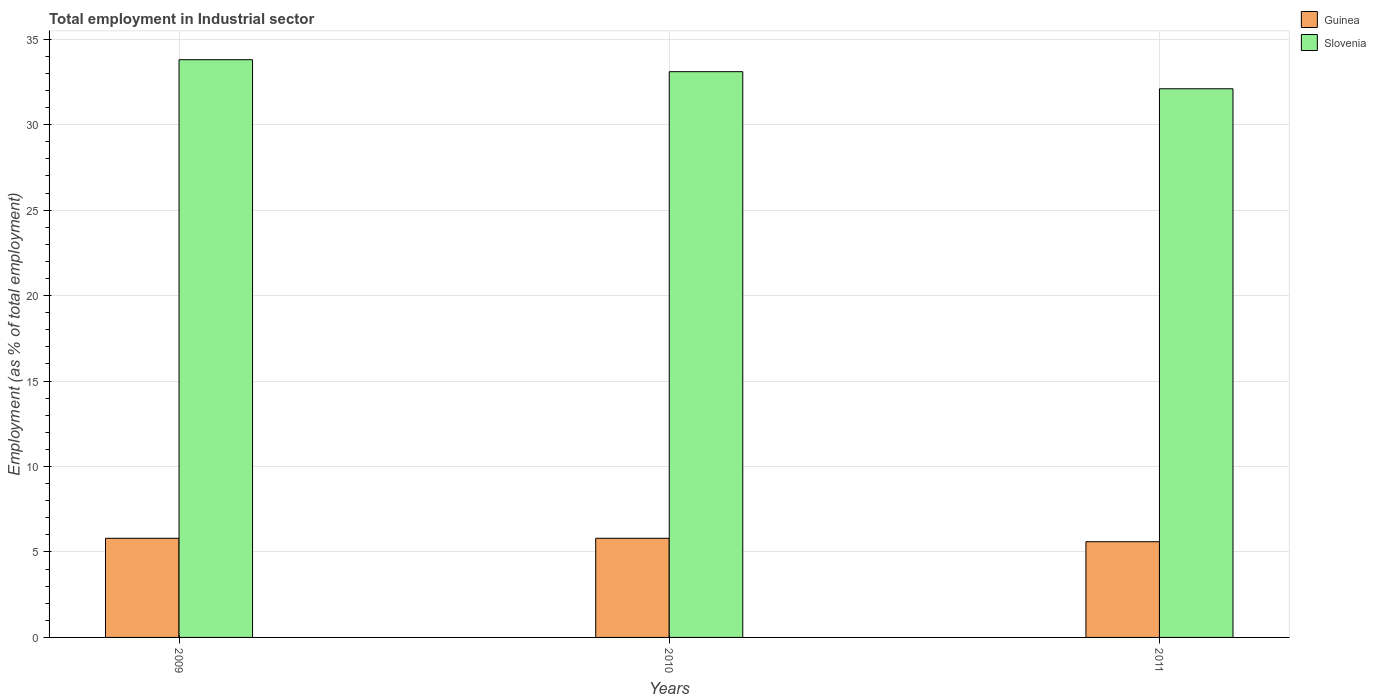How many different coloured bars are there?
Your answer should be compact. 2. How many groups of bars are there?
Make the answer very short. 3. Are the number of bars per tick equal to the number of legend labels?
Make the answer very short. Yes. How many bars are there on the 3rd tick from the left?
Your response must be concise. 2. What is the label of the 2nd group of bars from the left?
Give a very brief answer. 2010. In how many cases, is the number of bars for a given year not equal to the number of legend labels?
Your answer should be compact. 0. What is the employment in industrial sector in Guinea in 2011?
Offer a terse response. 5.6. Across all years, what is the maximum employment in industrial sector in Slovenia?
Ensure brevity in your answer.  33.8. Across all years, what is the minimum employment in industrial sector in Guinea?
Provide a succinct answer. 5.6. In which year was the employment in industrial sector in Guinea maximum?
Give a very brief answer. 2009. In which year was the employment in industrial sector in Guinea minimum?
Keep it short and to the point. 2011. What is the total employment in industrial sector in Slovenia in the graph?
Ensure brevity in your answer.  99. What is the difference between the employment in industrial sector in Guinea in 2010 and that in 2011?
Ensure brevity in your answer.  0.2. What is the difference between the employment in industrial sector in Guinea in 2010 and the employment in industrial sector in Slovenia in 2009?
Your answer should be compact. -28. What is the average employment in industrial sector in Guinea per year?
Keep it short and to the point. 5.73. In the year 2009, what is the difference between the employment in industrial sector in Guinea and employment in industrial sector in Slovenia?
Provide a succinct answer. -28. What is the ratio of the employment in industrial sector in Guinea in 2009 to that in 2011?
Provide a succinct answer. 1.04. What is the difference between the highest and the second highest employment in industrial sector in Slovenia?
Make the answer very short. 0.7. What is the difference between the highest and the lowest employment in industrial sector in Slovenia?
Your answer should be very brief. 1.7. In how many years, is the employment in industrial sector in Slovenia greater than the average employment in industrial sector in Slovenia taken over all years?
Your answer should be very brief. 2. Is the sum of the employment in industrial sector in Slovenia in 2009 and 2010 greater than the maximum employment in industrial sector in Guinea across all years?
Give a very brief answer. Yes. What does the 1st bar from the left in 2009 represents?
Provide a short and direct response. Guinea. What does the 2nd bar from the right in 2009 represents?
Make the answer very short. Guinea. Are all the bars in the graph horizontal?
Your answer should be very brief. No. How many years are there in the graph?
Make the answer very short. 3. Does the graph contain any zero values?
Ensure brevity in your answer.  No. How are the legend labels stacked?
Give a very brief answer. Vertical. What is the title of the graph?
Offer a very short reply. Total employment in Industrial sector. Does "High income" appear as one of the legend labels in the graph?
Provide a succinct answer. No. What is the label or title of the Y-axis?
Keep it short and to the point. Employment (as % of total employment). What is the Employment (as % of total employment) of Guinea in 2009?
Your answer should be compact. 5.8. What is the Employment (as % of total employment) in Slovenia in 2009?
Ensure brevity in your answer.  33.8. What is the Employment (as % of total employment) in Guinea in 2010?
Keep it short and to the point. 5.8. What is the Employment (as % of total employment) in Slovenia in 2010?
Offer a very short reply. 33.1. What is the Employment (as % of total employment) in Guinea in 2011?
Provide a short and direct response. 5.6. What is the Employment (as % of total employment) in Slovenia in 2011?
Provide a short and direct response. 32.1. Across all years, what is the maximum Employment (as % of total employment) in Guinea?
Provide a succinct answer. 5.8. Across all years, what is the maximum Employment (as % of total employment) in Slovenia?
Provide a succinct answer. 33.8. Across all years, what is the minimum Employment (as % of total employment) of Guinea?
Your response must be concise. 5.6. Across all years, what is the minimum Employment (as % of total employment) in Slovenia?
Make the answer very short. 32.1. What is the total Employment (as % of total employment) of Slovenia in the graph?
Make the answer very short. 99. What is the difference between the Employment (as % of total employment) in Guinea in 2009 and that in 2011?
Your response must be concise. 0.2. What is the difference between the Employment (as % of total employment) of Guinea in 2009 and the Employment (as % of total employment) of Slovenia in 2010?
Give a very brief answer. -27.3. What is the difference between the Employment (as % of total employment) of Guinea in 2009 and the Employment (as % of total employment) of Slovenia in 2011?
Your answer should be compact. -26.3. What is the difference between the Employment (as % of total employment) in Guinea in 2010 and the Employment (as % of total employment) in Slovenia in 2011?
Offer a very short reply. -26.3. What is the average Employment (as % of total employment) in Guinea per year?
Your answer should be very brief. 5.73. In the year 2009, what is the difference between the Employment (as % of total employment) of Guinea and Employment (as % of total employment) of Slovenia?
Keep it short and to the point. -28. In the year 2010, what is the difference between the Employment (as % of total employment) of Guinea and Employment (as % of total employment) of Slovenia?
Your response must be concise. -27.3. In the year 2011, what is the difference between the Employment (as % of total employment) of Guinea and Employment (as % of total employment) of Slovenia?
Provide a succinct answer. -26.5. What is the ratio of the Employment (as % of total employment) of Slovenia in 2009 to that in 2010?
Make the answer very short. 1.02. What is the ratio of the Employment (as % of total employment) in Guinea in 2009 to that in 2011?
Provide a succinct answer. 1.04. What is the ratio of the Employment (as % of total employment) in Slovenia in 2009 to that in 2011?
Offer a very short reply. 1.05. What is the ratio of the Employment (as % of total employment) in Guinea in 2010 to that in 2011?
Offer a very short reply. 1.04. What is the ratio of the Employment (as % of total employment) in Slovenia in 2010 to that in 2011?
Keep it short and to the point. 1.03. What is the difference between the highest and the second highest Employment (as % of total employment) of Guinea?
Provide a short and direct response. 0. What is the difference between the highest and the second highest Employment (as % of total employment) in Slovenia?
Ensure brevity in your answer.  0.7. What is the difference between the highest and the lowest Employment (as % of total employment) in Guinea?
Provide a succinct answer. 0.2. 